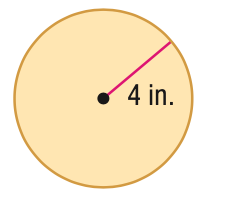Question: Find the perimeter or circumference of the figure. Round to the nearest tenth.
Choices:
A. 12.6
B. 24
C. 25.1
D. 50.2
Answer with the letter. Answer: C 